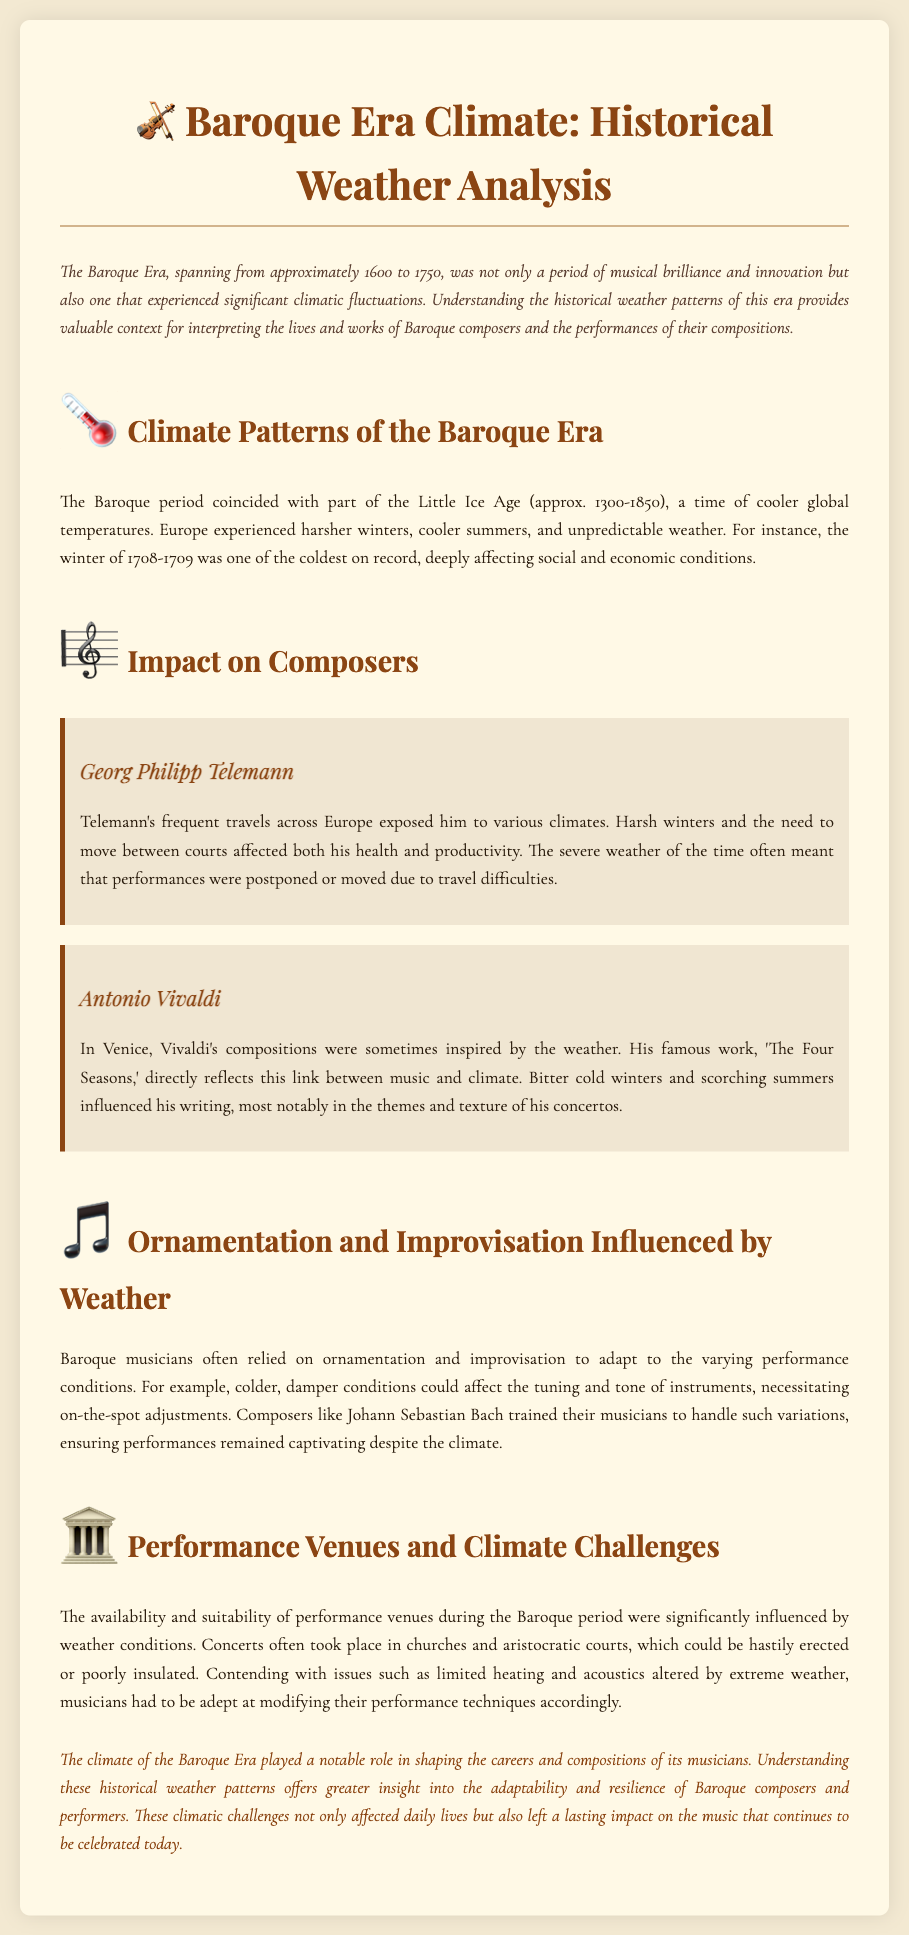What era is covered in this document? The document discusses the Baroque Era, spanning from approximately 1600 to 1750.
Answer: Baroque Era What climatic period coincided with the Baroque Era? The Baroque period coincided with part of the Little Ice Age (approx. 1300-1850).
Answer: Little Ice Age Which composer was inspired by the weather in Venice? Antonio Vivaldi's compositions were inspired by the weather in Venice.
Answer: Antonio Vivaldi What was one of the coldest winters on record during the Baroque Era? The winter of 1708-1709 was one of the coldest on record.
Answer: 1708-1709 How did weather affect Telemann's productivity? Harsh winters and the need to move between courts affected both his health and productivity.
Answer: Health and productivity What type of venues were frequently used for performances in the Baroque Era? Concerts often took place in churches and aristocratic courts.
Answer: Churches and aristocratic courts How did Baroque musicians adapt to varying performance conditions? Musicians relied on ornamentation and improvisation to adapt to the varying performance conditions.
Answer: Ornamentation and improvisation Which composer trained musicians to handle climate variations? Johann Sebastian Bach trained his musicians to handle such variations.
Answer: Johann Sebastian Bach What was affected by extreme weather during performances? Issues such as limited heating and acoustics altered by extreme weather.
Answer: Limited heating and acoustics 